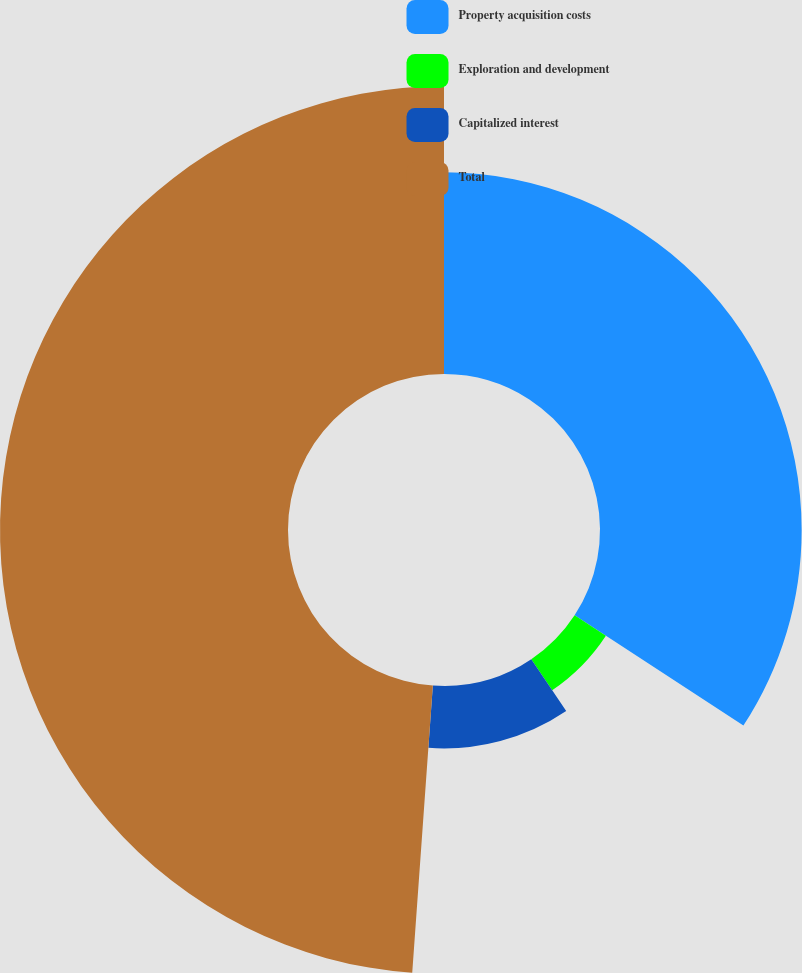Convert chart. <chart><loc_0><loc_0><loc_500><loc_500><pie_chart><fcel>Property acquisition costs<fcel>Exploration and development<fcel>Capitalized interest<fcel>Total<nl><fcel>34.21%<fcel>6.34%<fcel>10.59%<fcel>48.86%<nl></chart> 